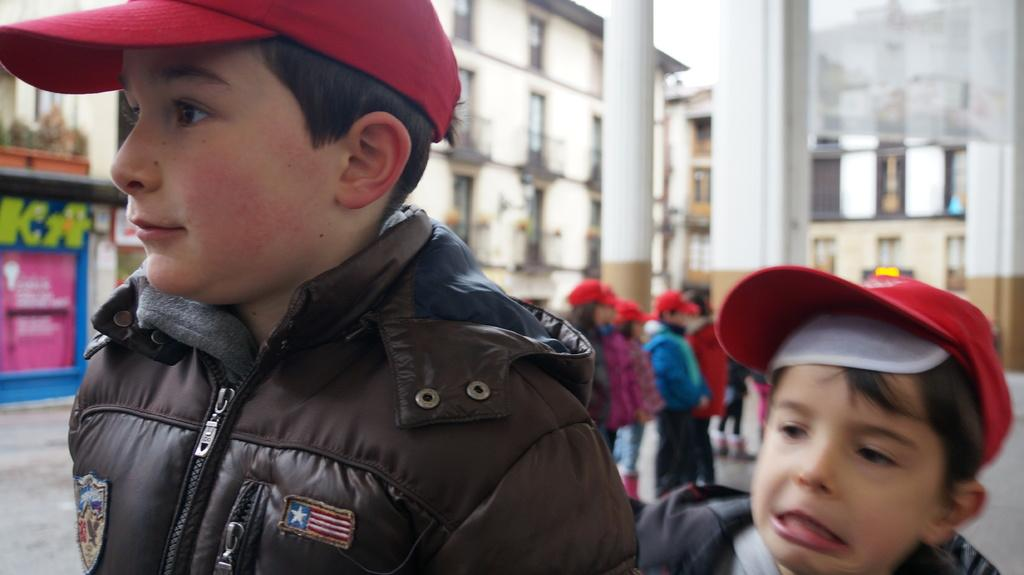How many children are visible in the image? There are two children standing in the image, with additional children standing behind them. What can be seen in the background of the image? There are pillars and buildings visible in the background of the image. What type of tent is set up in the image? There is no tent present in the image; it features children standing in front of pillars and buildings. 